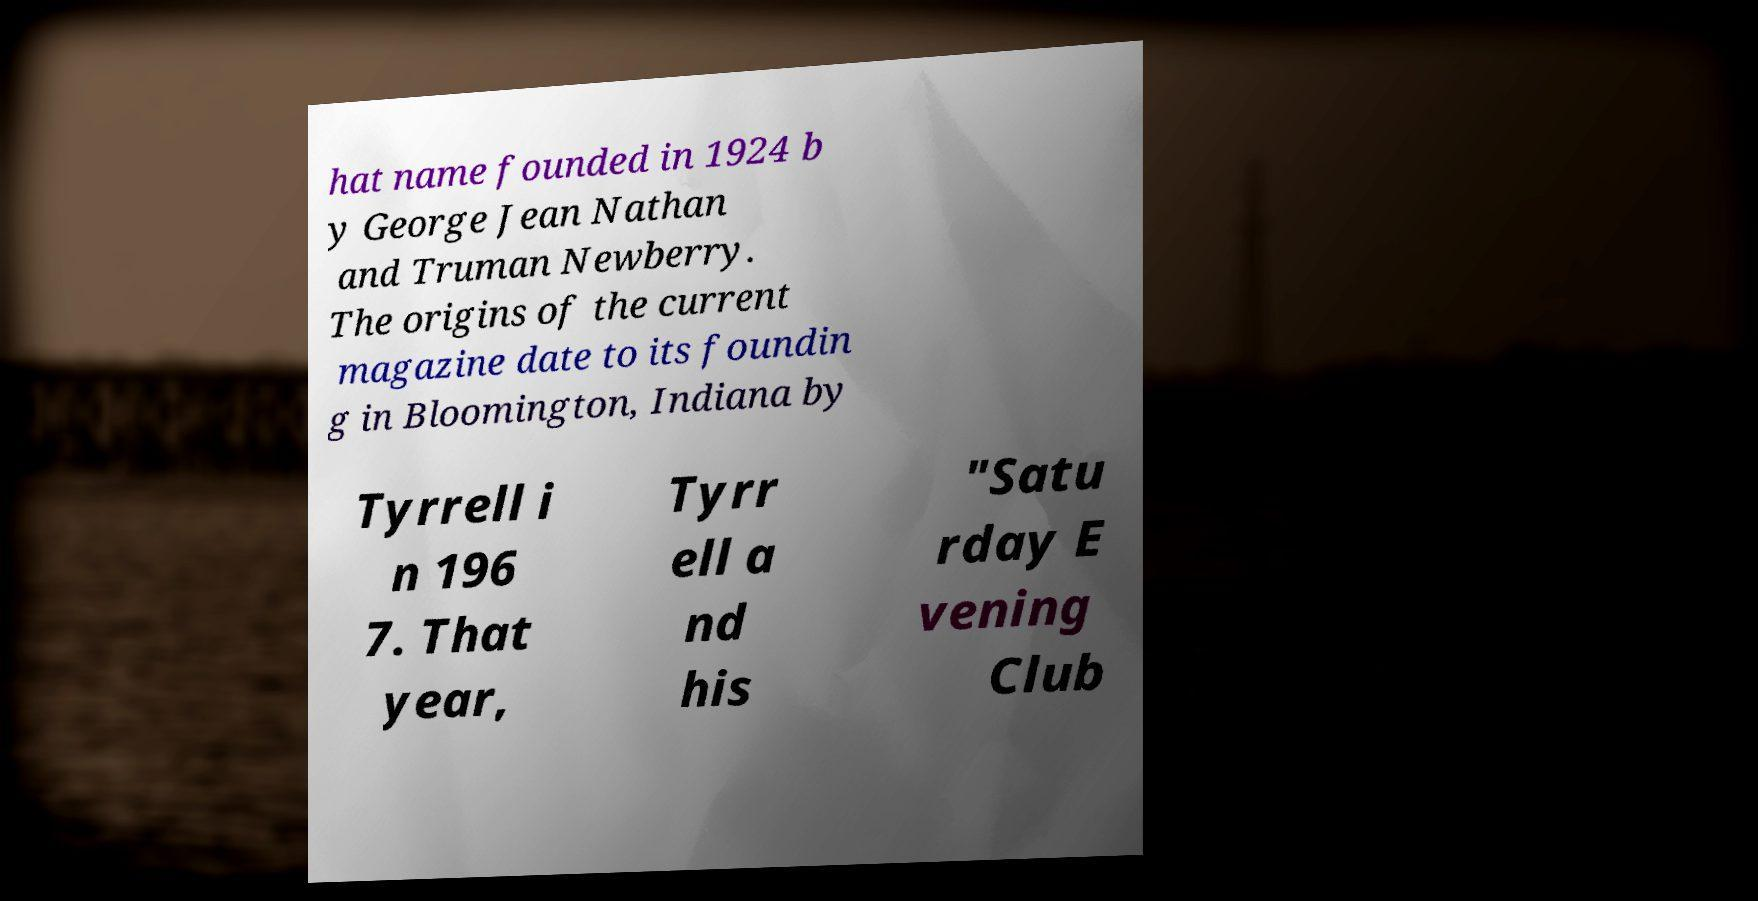Can you accurately transcribe the text from the provided image for me? hat name founded in 1924 b y George Jean Nathan and Truman Newberry. The origins of the current magazine date to its foundin g in Bloomington, Indiana by Tyrrell i n 196 7. That year, Tyrr ell a nd his "Satu rday E vening Club 